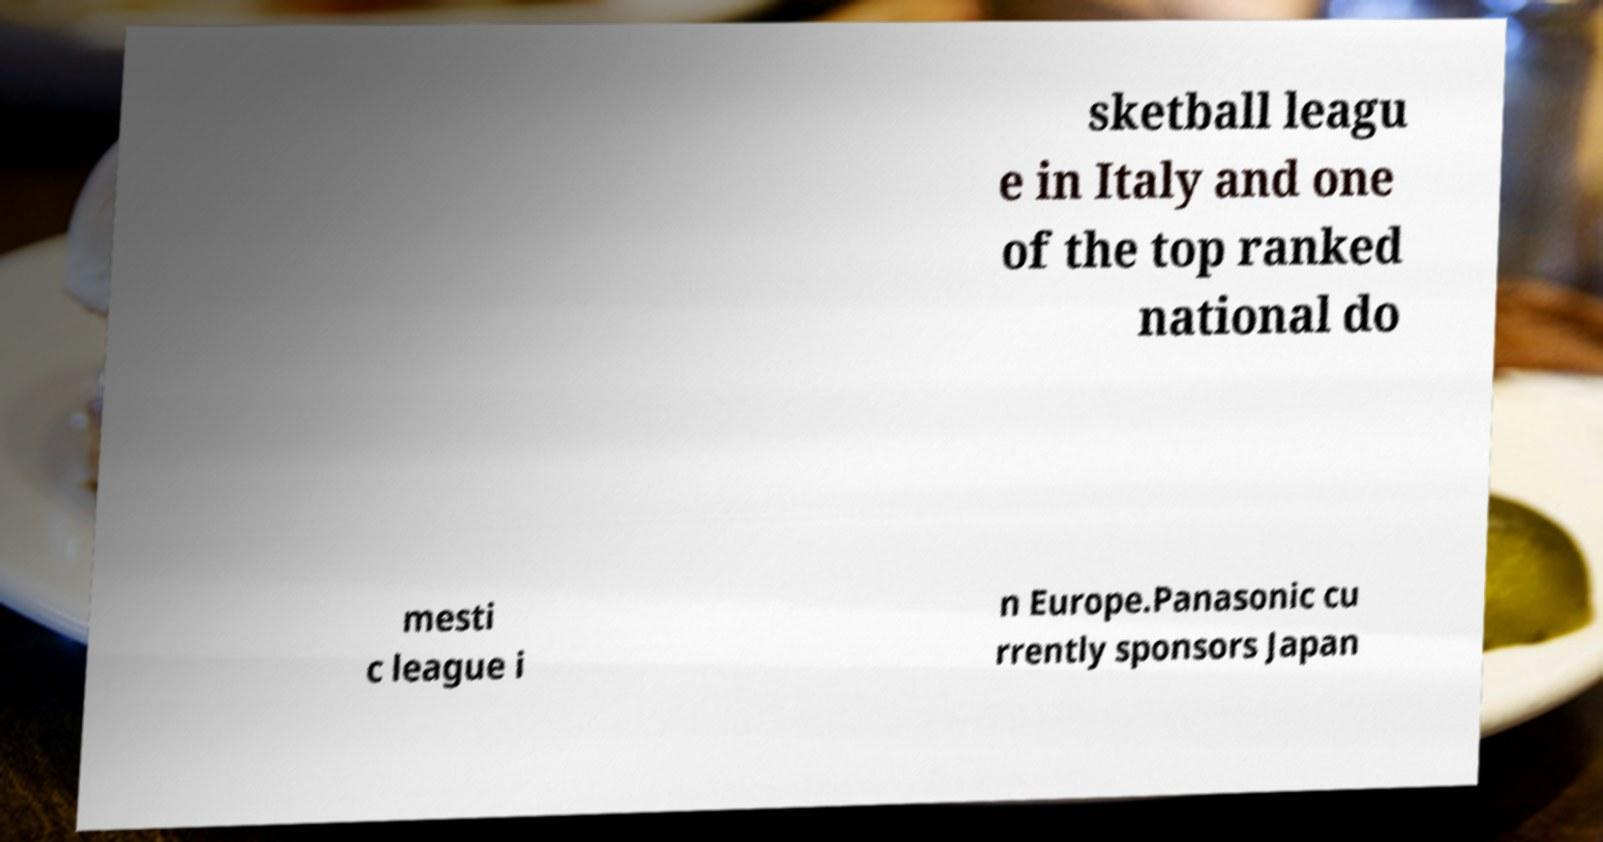Could you extract and type out the text from this image? sketball leagu e in Italy and one of the top ranked national do mesti c league i n Europe.Panasonic cu rrently sponsors Japan 